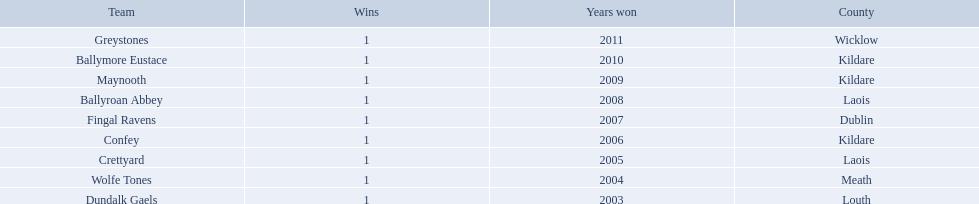Where is ballymore eustace from? Kildare. What teams other than ballymore eustace is from kildare? Maynooth, Confey. Between maynooth and confey, which won in 2009? Maynooth. 